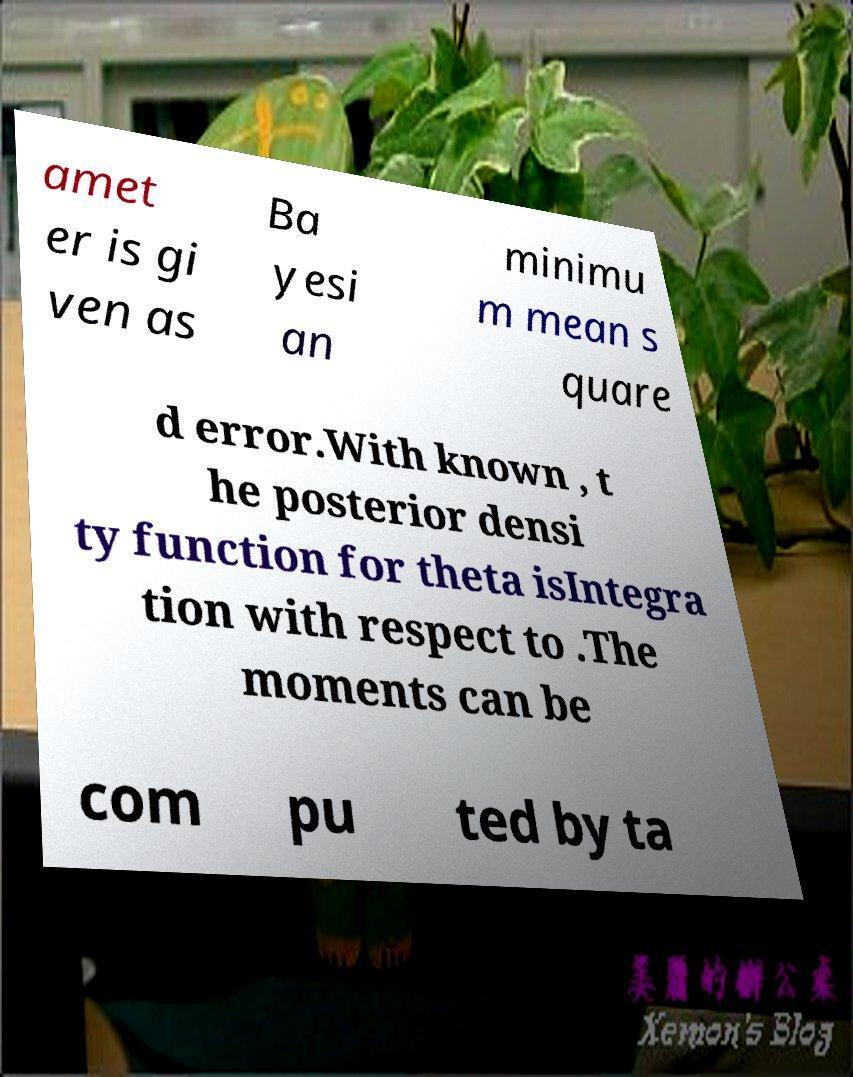What messages or text are displayed in this image? I need them in a readable, typed format. amet er is gi ven as Ba yesi an minimu m mean s quare d error.With known , t he posterior densi ty function for theta isIntegra tion with respect to .The moments can be com pu ted by ta 